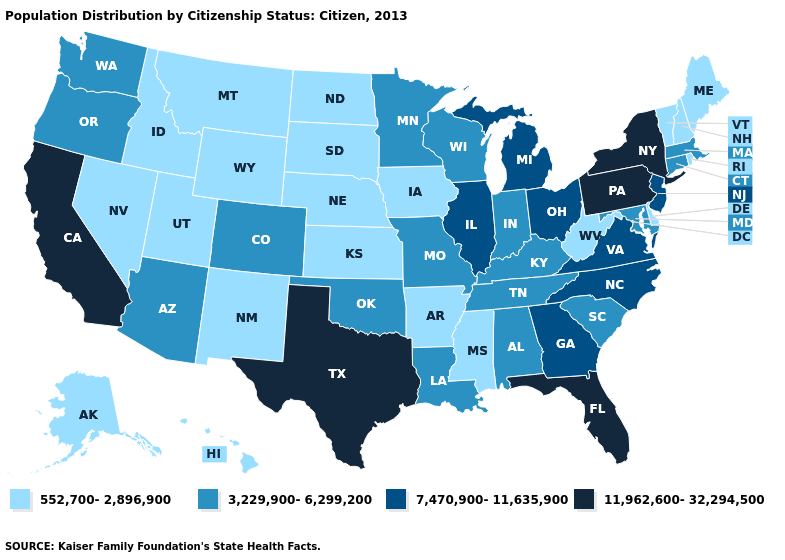Among the states that border Delaware , which have the lowest value?
Answer briefly. Maryland. Name the states that have a value in the range 11,962,600-32,294,500?
Answer briefly. California, Florida, New York, Pennsylvania, Texas. Name the states that have a value in the range 552,700-2,896,900?
Concise answer only. Alaska, Arkansas, Delaware, Hawaii, Idaho, Iowa, Kansas, Maine, Mississippi, Montana, Nebraska, Nevada, New Hampshire, New Mexico, North Dakota, Rhode Island, South Dakota, Utah, Vermont, West Virginia, Wyoming. What is the value of North Dakota?
Quick response, please. 552,700-2,896,900. Among the states that border Arkansas , which have the lowest value?
Quick response, please. Mississippi. Name the states that have a value in the range 7,470,900-11,635,900?
Short answer required. Georgia, Illinois, Michigan, New Jersey, North Carolina, Ohio, Virginia. What is the highest value in the USA?
Write a very short answer. 11,962,600-32,294,500. How many symbols are there in the legend?
Give a very brief answer. 4. What is the value of Massachusetts?
Give a very brief answer. 3,229,900-6,299,200. Which states have the lowest value in the MidWest?
Short answer required. Iowa, Kansas, Nebraska, North Dakota, South Dakota. Name the states that have a value in the range 11,962,600-32,294,500?
Keep it brief. California, Florida, New York, Pennsylvania, Texas. What is the lowest value in states that border Massachusetts?
Keep it brief. 552,700-2,896,900. Is the legend a continuous bar?
Concise answer only. No. What is the value of New Jersey?
Write a very short answer. 7,470,900-11,635,900. 